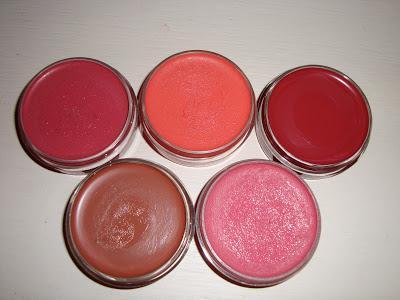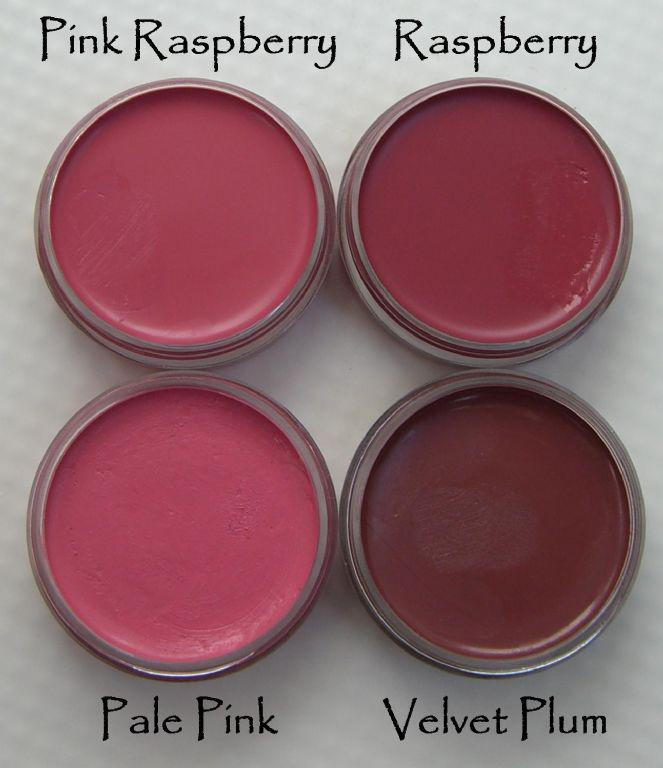The first image is the image on the left, the second image is the image on the right. Considering the images on both sides, is "There is at most 1 hand holding reddish makeup." valid? Answer yes or no. No. The first image is the image on the left, the second image is the image on the right. For the images displayed, is the sentence "One of the images in the pair shows a hand holding the makeup." factually correct? Answer yes or no. No. 